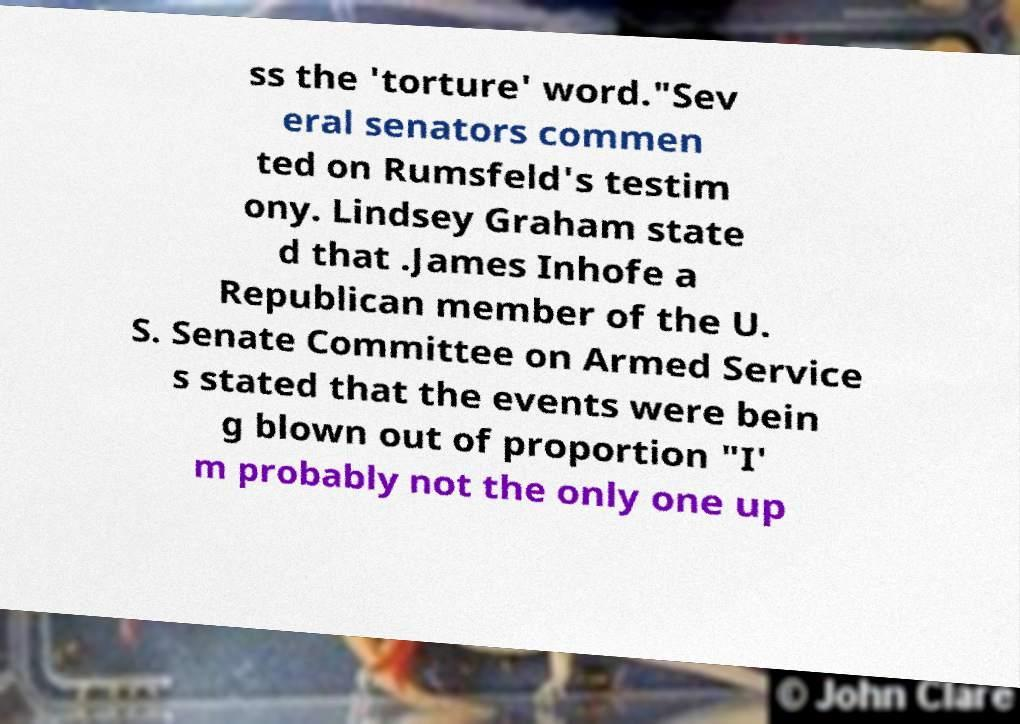Could you assist in decoding the text presented in this image and type it out clearly? ss the 'torture' word."Sev eral senators commen ted on Rumsfeld's testim ony. Lindsey Graham state d that .James Inhofe a Republican member of the U. S. Senate Committee on Armed Service s stated that the events were bein g blown out of proportion "I' m probably not the only one up 